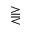<formula> <loc_0><loc_0><loc_500><loc_500>\gtreqqless</formula> 